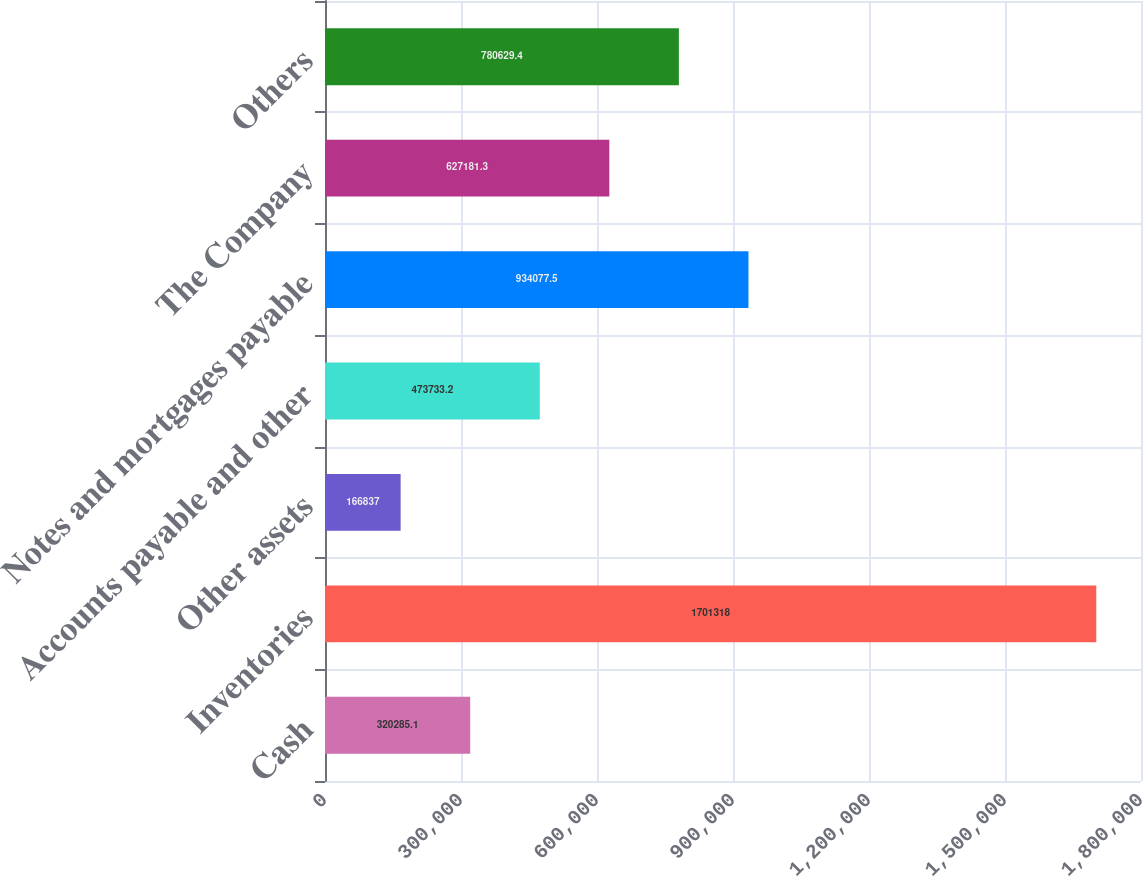Convert chart to OTSL. <chart><loc_0><loc_0><loc_500><loc_500><bar_chart><fcel>Cash<fcel>Inventories<fcel>Other assets<fcel>Accounts payable and other<fcel>Notes and mortgages payable<fcel>The Company<fcel>Others<nl><fcel>320285<fcel>1.70132e+06<fcel>166837<fcel>473733<fcel>934078<fcel>627181<fcel>780629<nl></chart> 